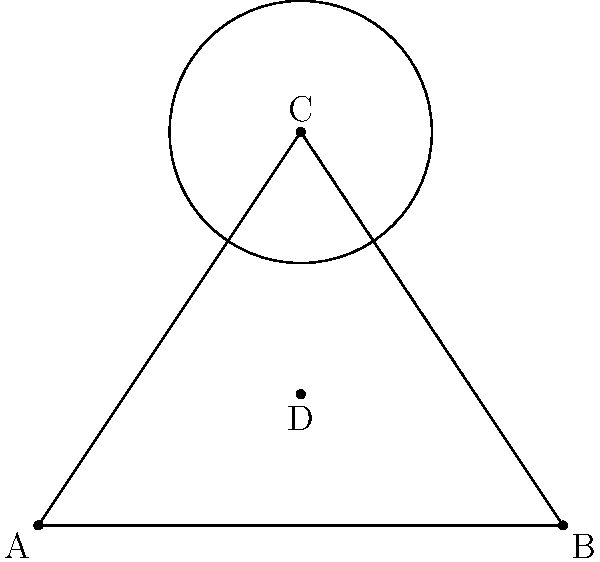In a salsa performance, dancers form a triangular formation on the dance floor. The lead couple is positioned at point C, forming the apex of an isosceles triangle ABC. Another couple at point D forms a circle with radius 1 unit, centered at C. If AB = 4 units and the height of the triangle (CD) is 2 units, what is the area of triangle ABC? Let's approach this step-by-step:

1) First, we need to find the base and height of the triangle.
   - We're given that AB = 4 units
   - The height CD = 2 units

2) In an isosceles triangle, the height bisects the base. So:
   - AD = DB = 2 units

3) Now we can use the formula for the area of a triangle:
   $$ \text{Area} = \frac{1}{2} \times \text{base} \times \text{height} $$

4) Substituting our values:
   $$ \text{Area} = \frac{1}{2} \times 4 \times 2 $$

5) Simplifying:
   $$ \text{Area} = 4 \text{ square units} $$

Thus, the area of the triangle formed by the dancers is 4 square units.
Answer: 4 square units 